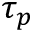<formula> <loc_0><loc_0><loc_500><loc_500>\tau _ { p }</formula> 